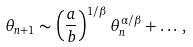<formula> <loc_0><loc_0><loc_500><loc_500>\theta _ { n + 1 } \sim \left ( \frac { a } { b } \right ) ^ { 1 / \beta } \theta _ { n } ^ { \alpha / \beta } + \dots \, ,</formula> 